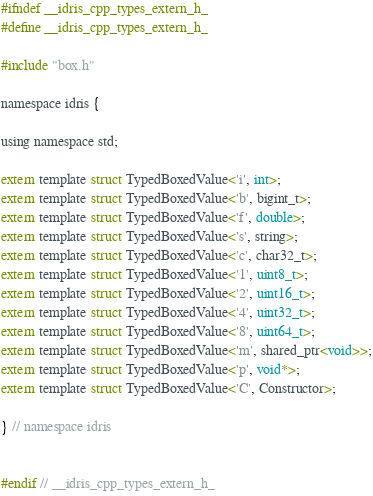Convert code to text. <code><loc_0><loc_0><loc_500><loc_500><_C_>#ifndef __idris_cpp_types_extern_h_
#define __idris_cpp_types_extern_h_

#include "box.h"

namespace idris {

using namespace std;

extern template struct TypedBoxedValue<'i', int>;
extern template struct TypedBoxedValue<'b', bigint_t>;
extern template struct TypedBoxedValue<'f', double>;
extern template struct TypedBoxedValue<'s', string>;
extern template struct TypedBoxedValue<'c', char32_t>;
extern template struct TypedBoxedValue<'1', uint8_t>;
extern template struct TypedBoxedValue<'2', uint16_t>;
extern template struct TypedBoxedValue<'4', uint32_t>;
extern template struct TypedBoxedValue<'8', uint64_t>;
extern template struct TypedBoxedValue<'m', shared_ptr<void>>;
extern template struct TypedBoxedValue<'p', void*>;
extern template struct TypedBoxedValue<'C', Constructor>;

} // namespace idris


#endif // __idris_cpp_types_extern_h_
</code> 